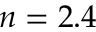Convert formula to latex. <formula><loc_0><loc_0><loc_500><loc_500>n = 2 . 4</formula> 